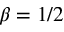Convert formula to latex. <formula><loc_0><loc_0><loc_500><loc_500>\beta = 1 / 2</formula> 